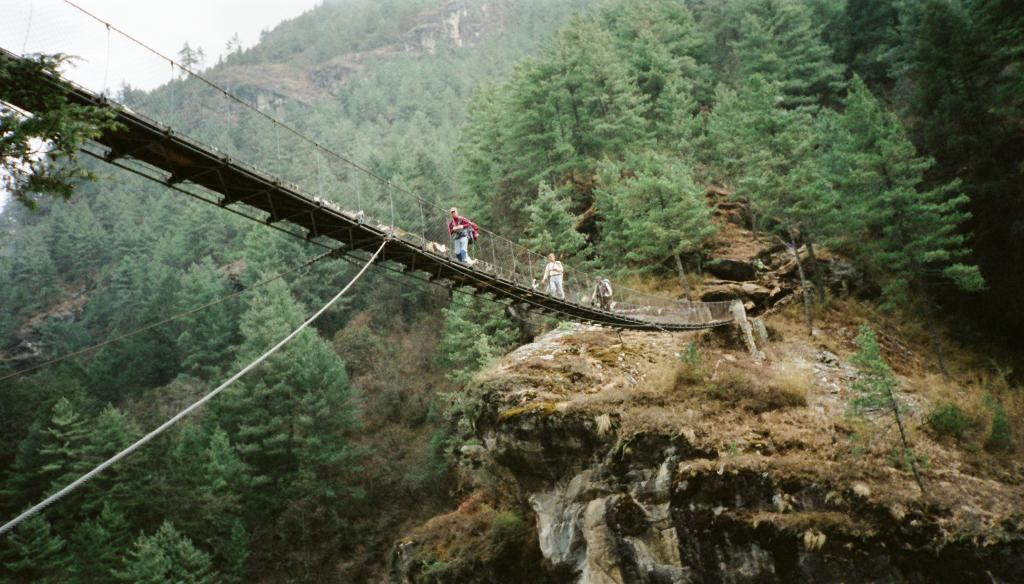What structure can be seen in the image? There is a bridge in the image. What are the people in the image doing? The people are walking on the bridge. What can be seen in the background of the image? There is a hill in the background of the image. What is covering the hill in the image? The hill is covered with trees. What is visible above the bridge and hill in the image? The sky is visible in the image. Can you see any cactus plants growing on the bridge in the image? There are no cactus plants visible on the bridge in the image. 